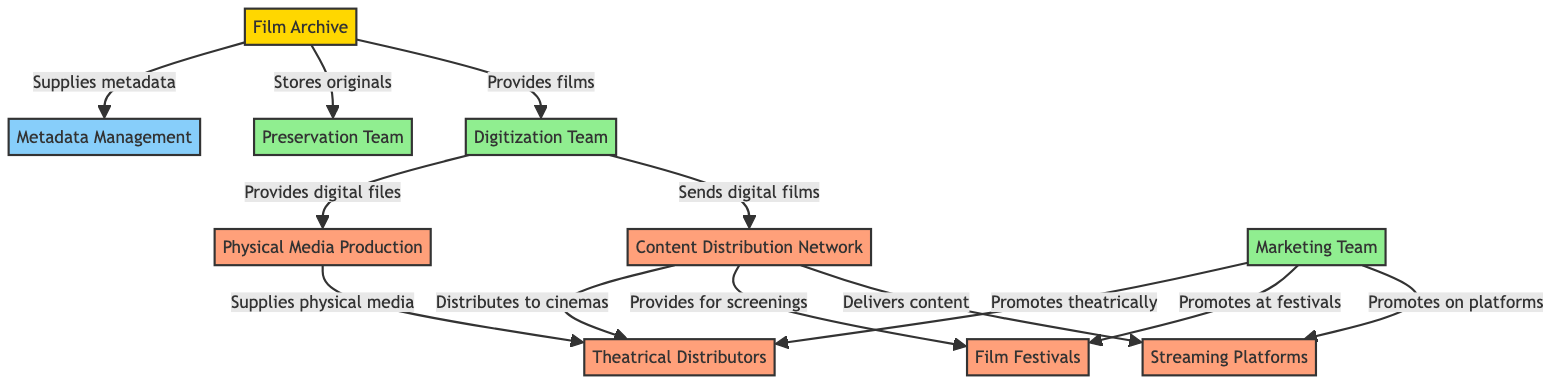What is the total number of nodes in the diagram? The diagram contains ten distinct entities, which are the nodes representing different aspects of the film distribution network.
Answer: 10 What is the role of the Digitization Team? The Digitization Team is responsible for converting films from physical formats to digital formats, as indicated by its description and connections from the Film Archive.
Answer: Converts films to digital formats Which node receives digital films from the Digitization Team? The Content Distribution Network receives digital films from the Digitization Team, as shown by the direct edge connecting these two nodes.
Answer: Content Distribution Network How many distribution outlets are mentioned in the diagram? The diagram specifies four distribution outlets: Streaming Platforms, Physical Media Production, Film Festivals, and Theatrical Distributors, identified as nodes that receive films from the Content Distribution Network.
Answer: 4 What does the Marketing Team do in relation to Streaming Platforms? The Marketing Team promotes films on Streaming Platforms, as directly indicated by the connection from the Marketing Team to the Streaming Platforms node.
Answer: Promotes on platforms Which team handles the maintenance of original film materials? The Preservation Team is responsible for the maintenance and preservation of original film materials, as described in its node information.
Answer: Preservation Team If the Content Distribution Network provides films for screenings, which node does it connect to? The Content Distribution Network connects to the Film Festivals node to provide films for screenings as indicated by their direct edge.
Answer: Film Festivals Which team would provide digital files to Physical Media Production? The Digitization Team provides digital files to Physical Media Production, as shown by the direct edge between these two nodes.
Answer: Digitization Team What is the main function of the Metadata Management system in the diagram? The Metadata Management system is responsible for managing detailed information about each film, as outlined in its description within the diagram.
Answer: Managing detailed information about each film How does the Film Archive interact with the Preservation Team? The Film Archive stores original films, and this relationship is represented by a direct edge leading from the Film Archive to the Preservation Team node.
Answer: Stores original films 